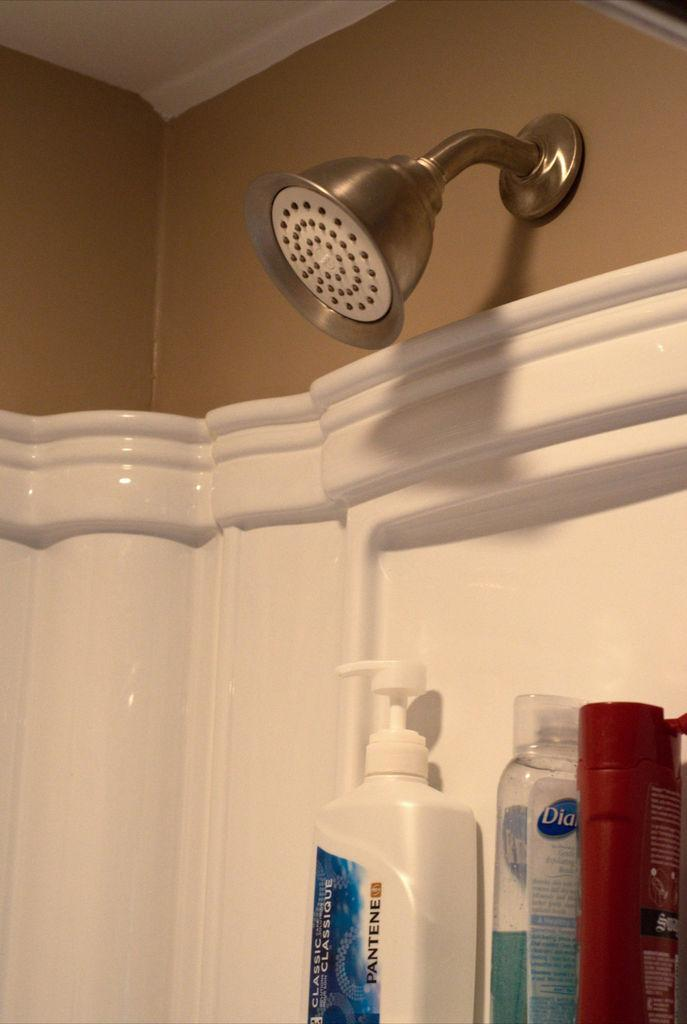What can be seen in the image related to personal hygiene? There is a shower in the image. How many bottles are visible in the image? There are three bottles in the image. What might be the purpose of the bottles in the image? The bottles look like shampoo bottles or creams, which are typically used for personal hygiene. What type of salt is visible in the frame in the image? There is no salt or frame present in the image. What is the cause of the bottles in the image? The cause of the bottles in the image is not mentioned in the provided facts; they are simply present in the image. 